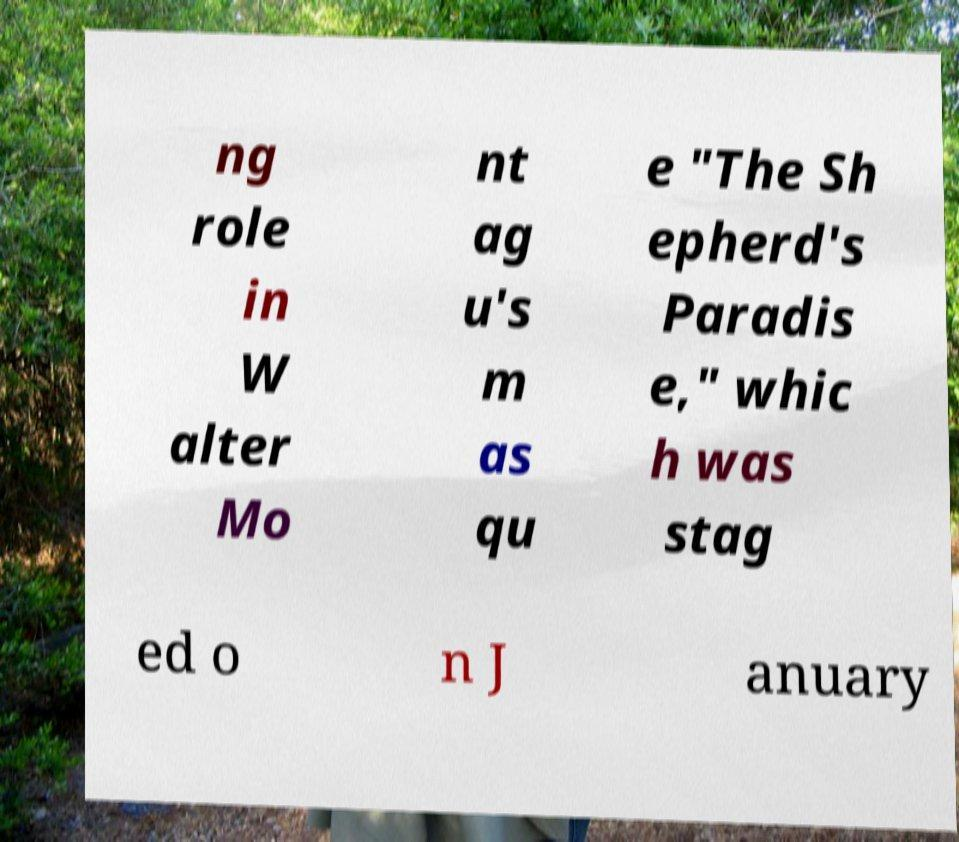Can you read and provide the text displayed in the image?This photo seems to have some interesting text. Can you extract and type it out for me? ng role in W alter Mo nt ag u's m as qu e "The Sh epherd's Paradis e," whic h was stag ed o n J anuary 